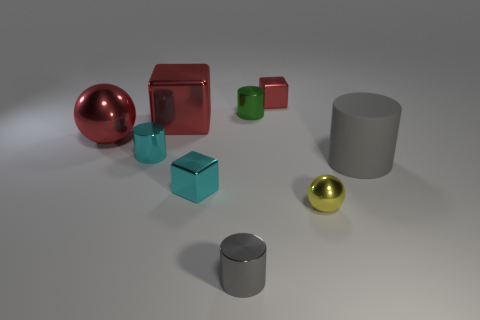Subtract 1 cylinders. How many cylinders are left? 3 Add 1 yellow things. How many objects exist? 10 Subtract all blocks. How many objects are left? 6 Add 8 small cyan cylinders. How many small cyan cylinders exist? 9 Subtract 0 purple blocks. How many objects are left? 9 Subtract all small purple objects. Subtract all large red metal objects. How many objects are left? 7 Add 4 small green shiny cylinders. How many small green shiny cylinders are left? 5 